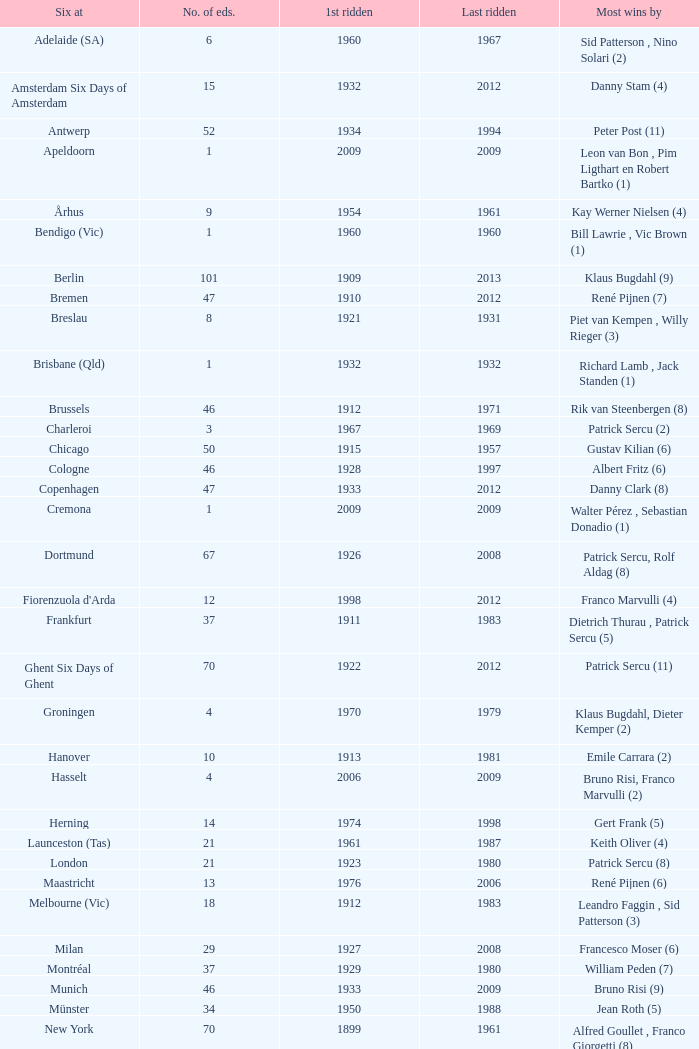How many editions have a most wins value of Franco Marvulli (4)? 1.0. 